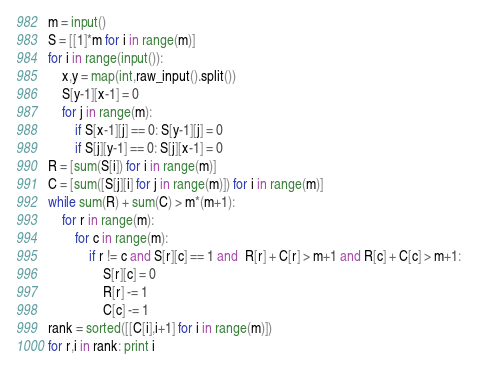<code> <loc_0><loc_0><loc_500><loc_500><_Python_>m = input()
S = [[1]*m for i in range(m)]
for i in range(input()):
	x,y = map(int,raw_input().split())
	S[y-1][x-1] = 0
	for j in range(m):
		if S[x-1][j] == 0: S[y-1][j] = 0
		if S[j][y-1] == 0: S[j][x-1] = 0
R = [sum(S[i]) for i in range(m)]
C = [sum([S[j][i] for j in range(m)]) for i in range(m)]
while sum(R) + sum(C) > m*(m+1):
	for r in range(m):
		for c in range(m):
			if r != c and S[r][c] == 1 and  R[r] + C[r] > m+1 and R[c] + C[c] > m+1:
				S[r][c] = 0
				R[r] -= 1
				C[c] -= 1
rank = sorted([[C[i],i+1] for i in range(m)])
for r,i in rank: print i</code> 